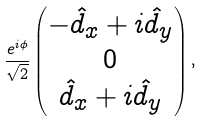Convert formula to latex. <formula><loc_0><loc_0><loc_500><loc_500>\frac { e ^ { i \phi } } { \sqrt { 2 } } \begin{pmatrix} - \hat { d } _ { x } + i \hat { d } _ { y } \\ 0 \\ \hat { d } _ { x } + i \hat { d } _ { y } \end{pmatrix} ,</formula> 